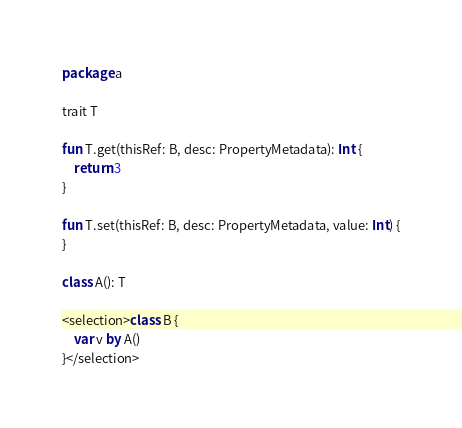Convert code to text. <code><loc_0><loc_0><loc_500><loc_500><_Kotlin_>package a

trait T

fun T.get(thisRef: B, desc: PropertyMetadata): Int {
    return 3
}

fun T.set(thisRef: B, desc: PropertyMetadata, value: Int) {
}

class A(): T

<selection>class B {
    var v by A()
}</selection></code> 